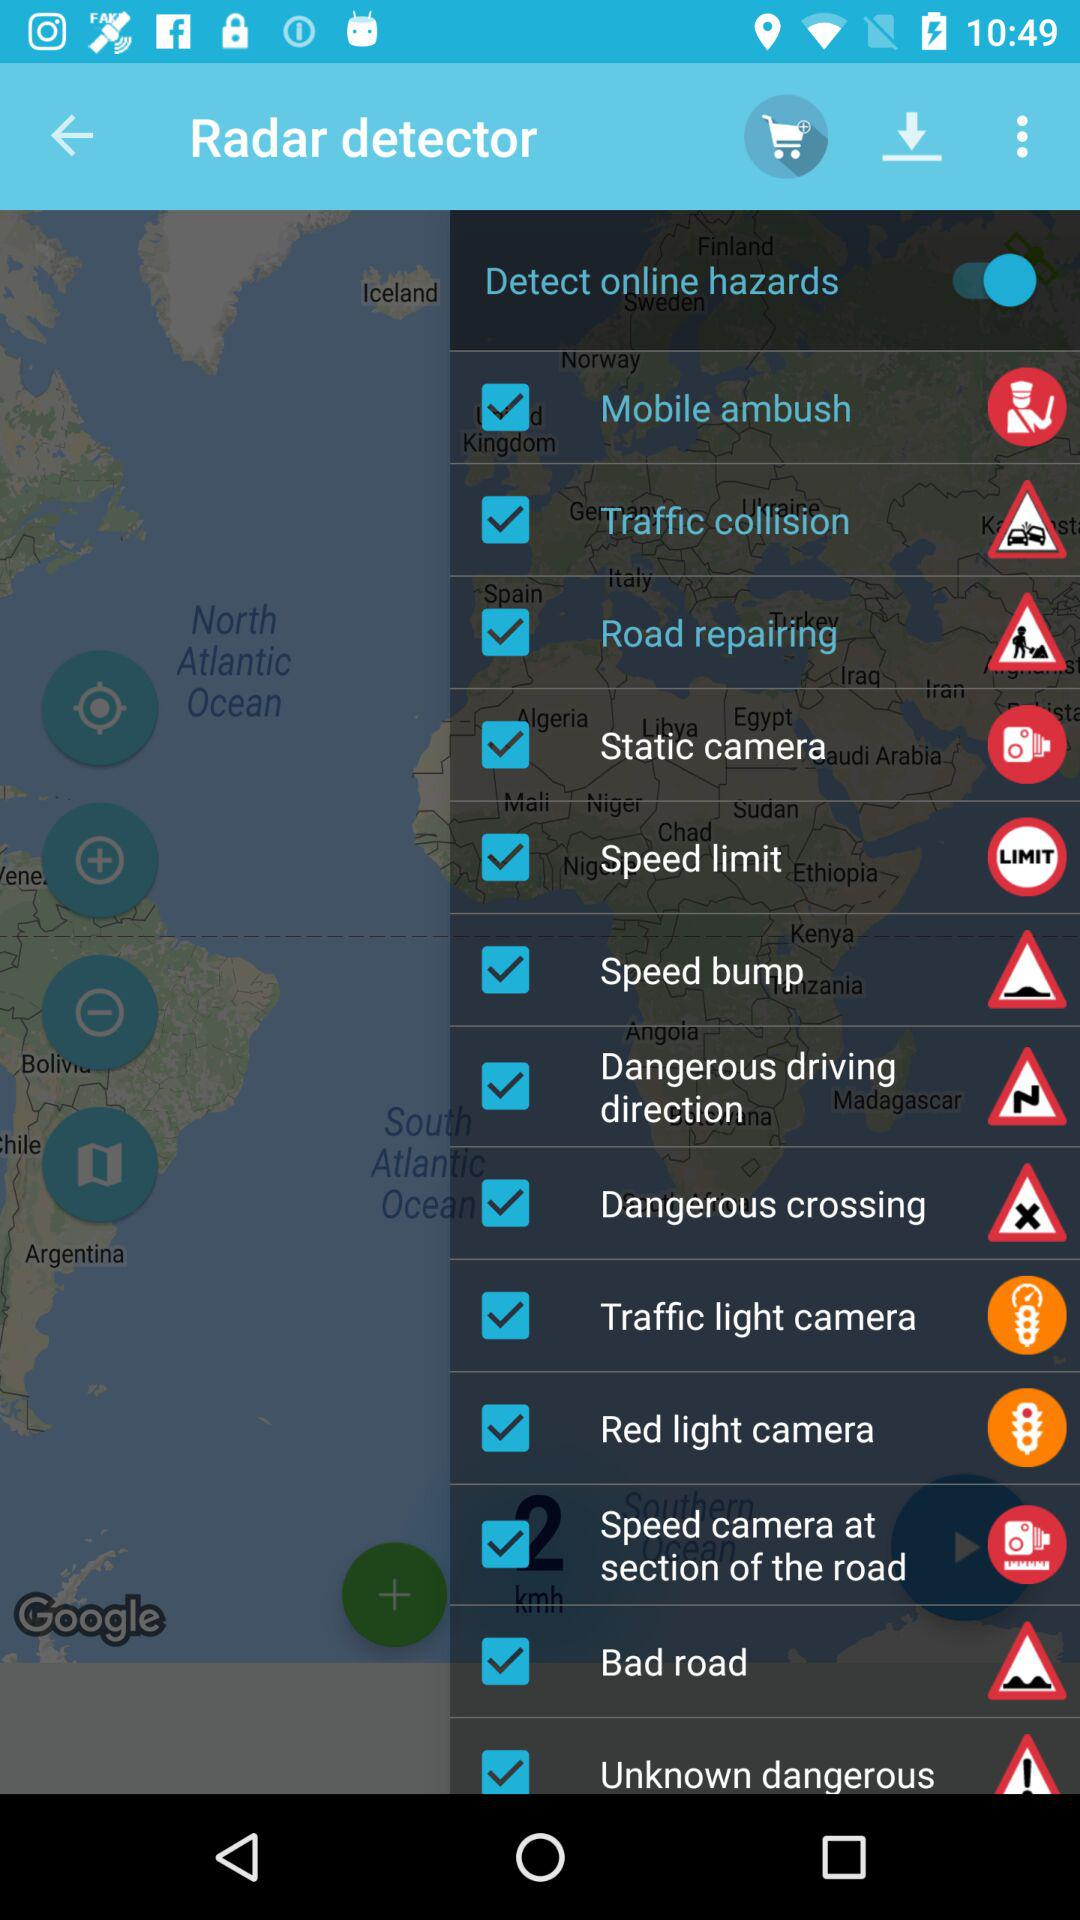What is the status of the "Detect online hazards"? The status is "on". 